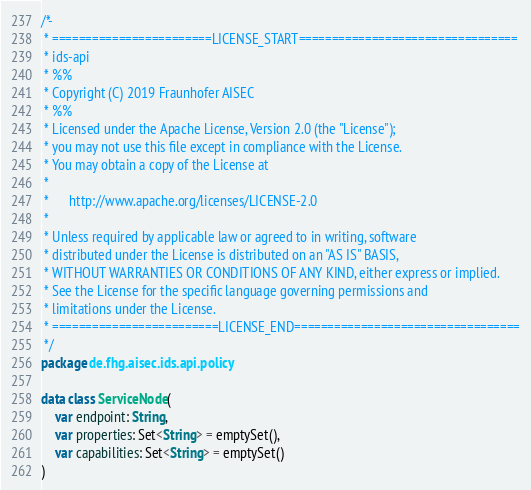<code> <loc_0><loc_0><loc_500><loc_500><_Kotlin_>/*-
 * ========================LICENSE_START=================================
 * ids-api
 * %%
 * Copyright (C) 2019 Fraunhofer AISEC
 * %%
 * Licensed under the Apache License, Version 2.0 (the "License");
 * you may not use this file except in compliance with the License.
 * You may obtain a copy of the License at
 *
 *      http://www.apache.org/licenses/LICENSE-2.0
 *
 * Unless required by applicable law or agreed to in writing, software
 * distributed under the License is distributed on an "AS IS" BASIS,
 * WITHOUT WARRANTIES OR CONDITIONS OF ANY KIND, either express or implied.
 * See the License for the specific language governing permissions and
 * limitations under the License.
 * =========================LICENSE_END==================================
 */
package de.fhg.aisec.ids.api.policy

data class ServiceNode(
    var endpoint: String,
    var properties: Set<String> = emptySet(),
    var capabilities: Set<String> = emptySet()
)
</code> 